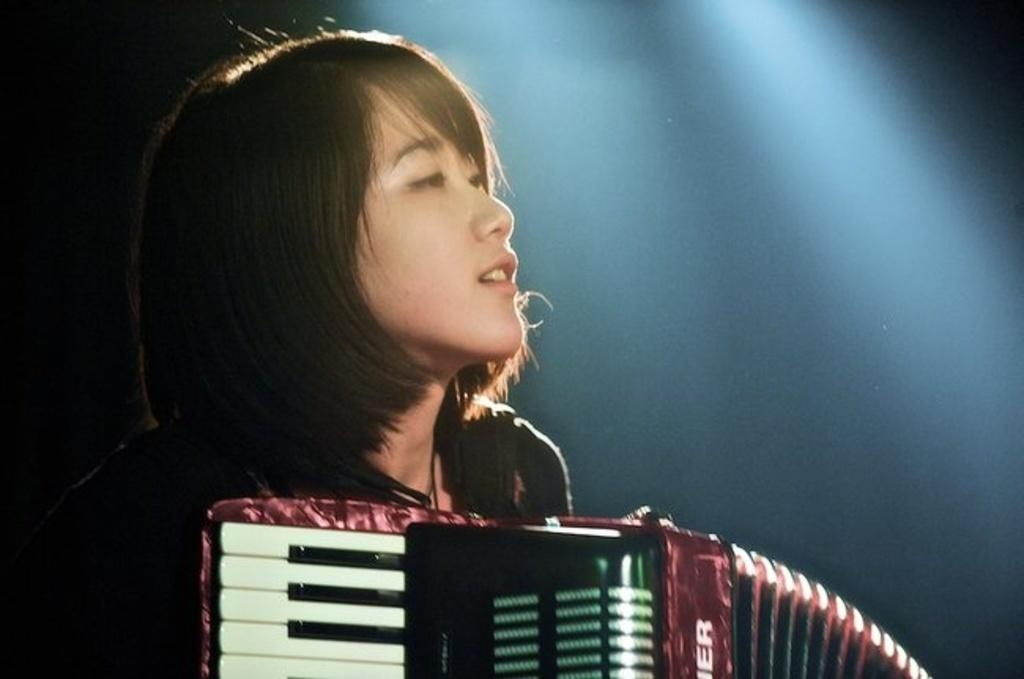Who is the main subject in the image? There is a woman in the image. What is the woman doing in the image? The woman is playing a harmonium. What type of news can be heard coming from the woman's harmonium in the image? The harmonium does not produce news; it is a musical instrument used to play melodies. 